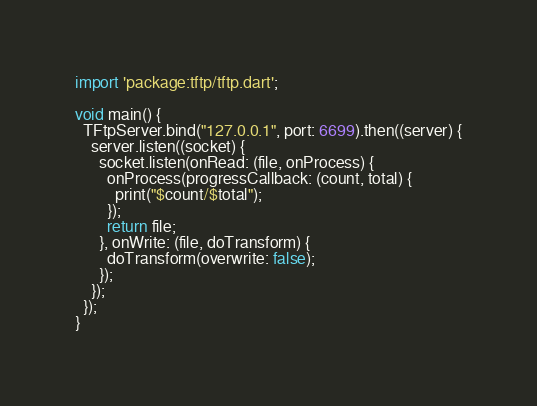<code> <loc_0><loc_0><loc_500><loc_500><_Dart_>import 'package:tftp/tftp.dart';

void main() {
  TFtpServer.bind("127.0.0.1", port: 6699).then((server) {
    server.listen((socket) {
      socket.listen(onRead: (file, onProcess) {
        onProcess(progressCallback: (count, total) {
          print("$count/$total");
        });
        return file;
      }, onWrite: (file, doTransform) {
        doTransform(overwrite: false);
      });
    });
  });
}
</code> 